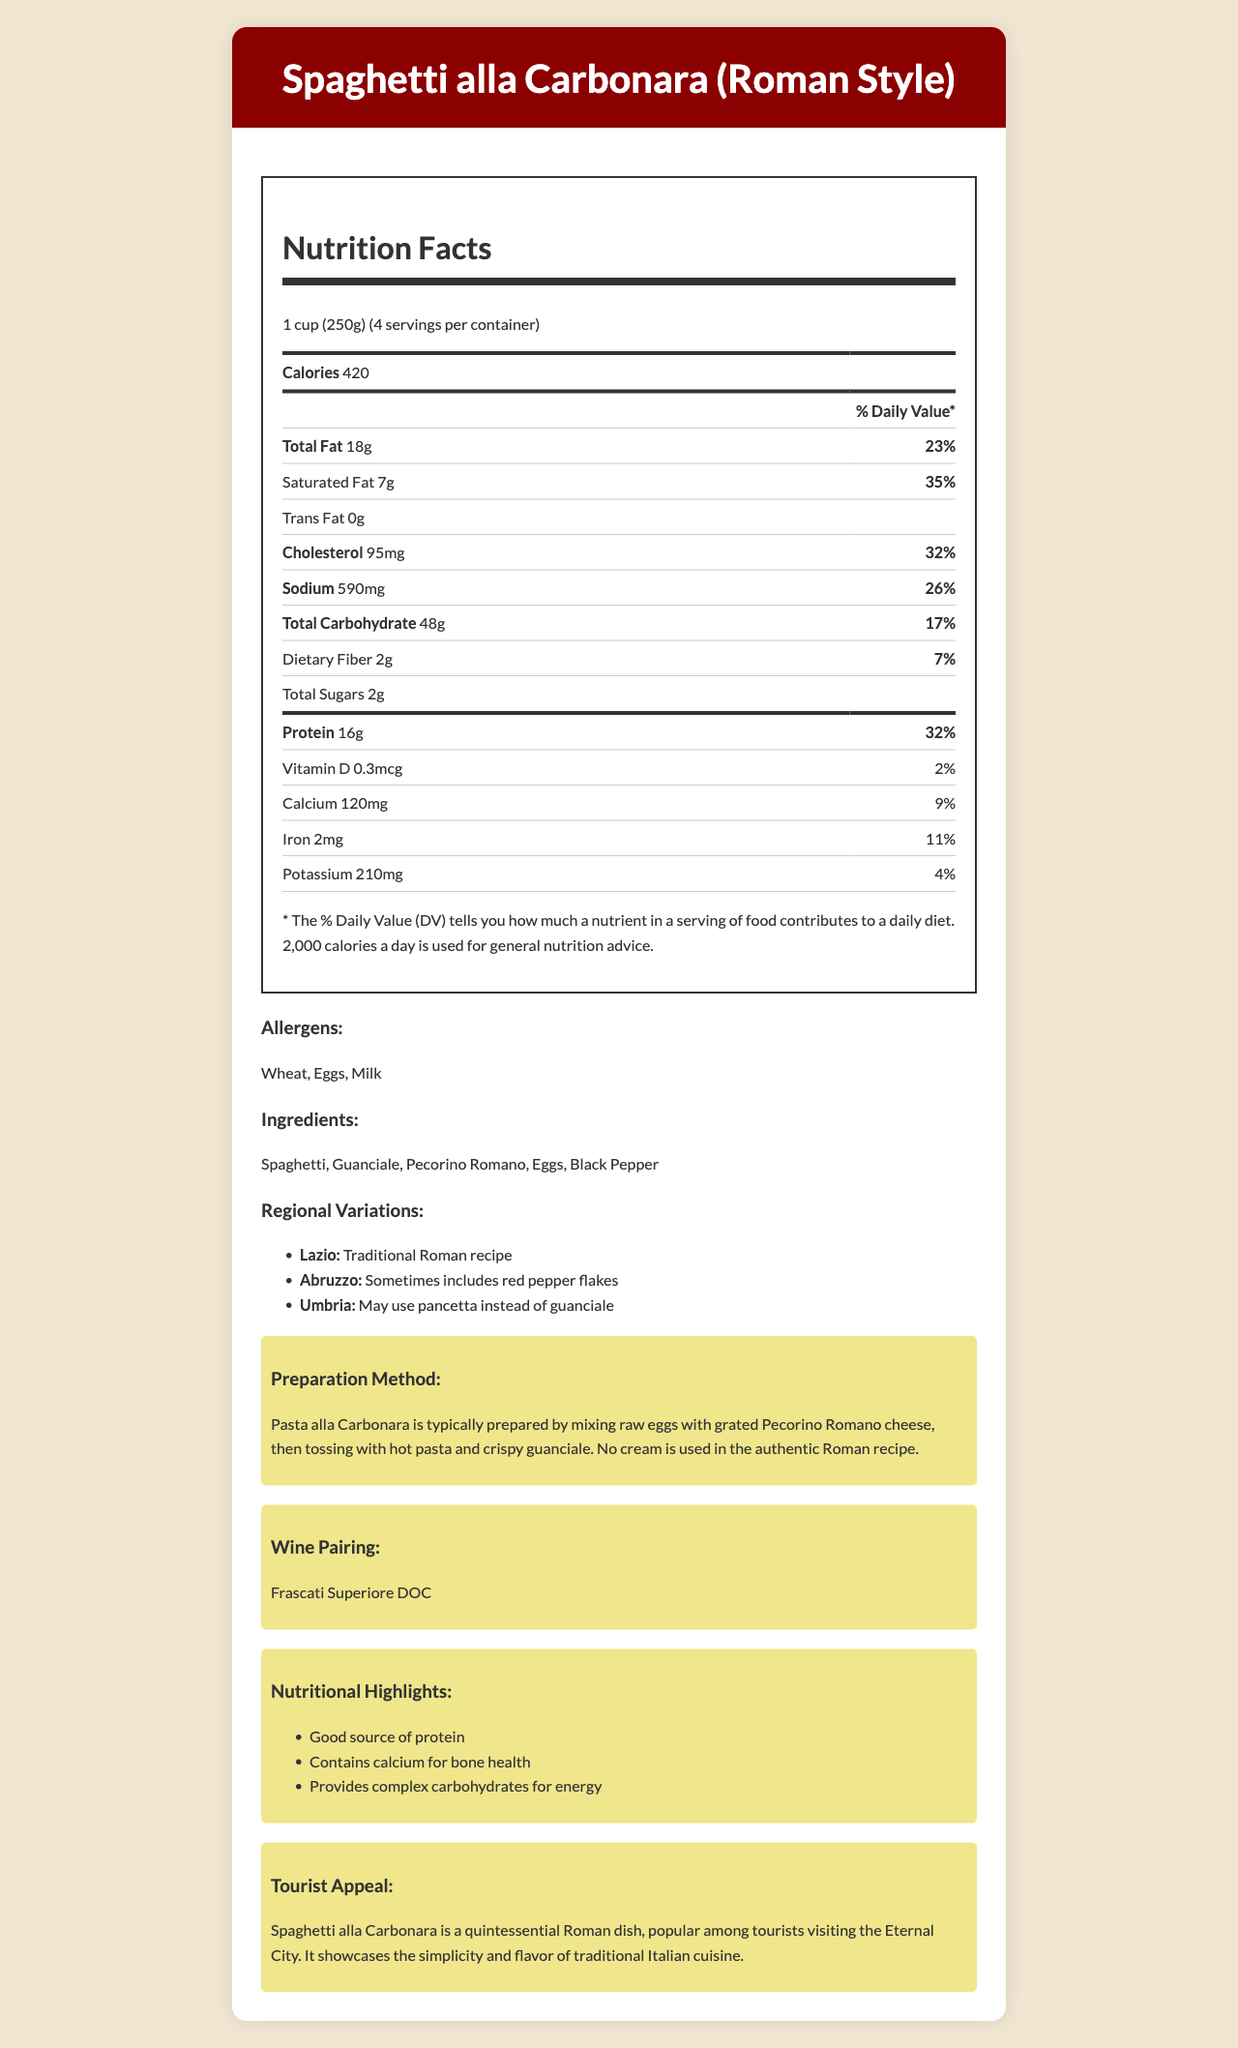what is the serving size of Spaghetti alla Carbonara? The serving size is mentioned at the top of the nutrition facts label: "1 cup (250g)".
Answer: 1 cup (250g) how many calories are in one serving? The calories are listed near the top of the nutrition facts label: "Calories 420".
Answer: 420 what is the percentage daily value of saturated fat? The percentage daily value for saturated fat is indicated as "35%" next to the saturated fat amount.
Answer: 35% how much protein does one serving contain? The document states that one serving of Spaghetti alla Carbonara contains "Protein 16g".
Answer: 16g name three allergens present in this dish. The allergens are listed under the "Allergens" section: "Wheat, Eggs, Milk".
Answer: Wheat, Eggs, Milk which ingredient is used in the authentic Roman recipe but might be substituted in the Umbrian variation? A. Guanciale B. Pecorino Romano C. Black Pepper D. Eggs According to the regional variations section, "Umbrian variation may use pancetta instead of guanciale".
Answer: A what is the suggested wine pairing for Spaghetti alla Carbonara? A. Chianti B. Barolo C. Frascati Superiore DOC D. Pinot Grigio The wine pairing section recommends "Frascati Superiore DOC".
Answer: C does the document specify that no cream is used in the authentic Roman recipe? The preparation method specifies that "No cream is used in the authentic Roman recipe".
Answer: Yes what additional item is sometimes included in the Abruzzo variation of the dish? The regional variations section notes that the Abruzzo variation "Sometimes includes red pepper flakes".
Answer: Red pepper flakes summarize the main nutritional benefits of Spaghetti alla Carbonara. The "Nutritional Highlights" section lists these three specific benefits.
Answer: Spaghetti alla Carbonara is a good source of protein, contains calcium for bone health, and provides complex carbohydrates for energy. which region's variation might include pancetta instead of guanciale? The regional variations section mentions that "Umbria may use pancetta instead of guanciale".
Answer: Umbria how much calcium is in one serving, and what is its daily value percentage? The nutrition facts label lists the amount of calcium as "120mg" and its daily value as "9%".
Answer: 120mg, 9% what temperature should the pasta and guanciale be when mixing them with eggs and cheese in the preparation method? The preparation method says they should be hot but does not specify an exact temperature.
Answer: Not enough information is Spaghetti alla Carbonara typically considered a low-fat dish based on the nutrition facts provided? The document lists 18g of total fat per serving, which is 23% of the daily value, indicating it is not low in fat.
Answer: No 